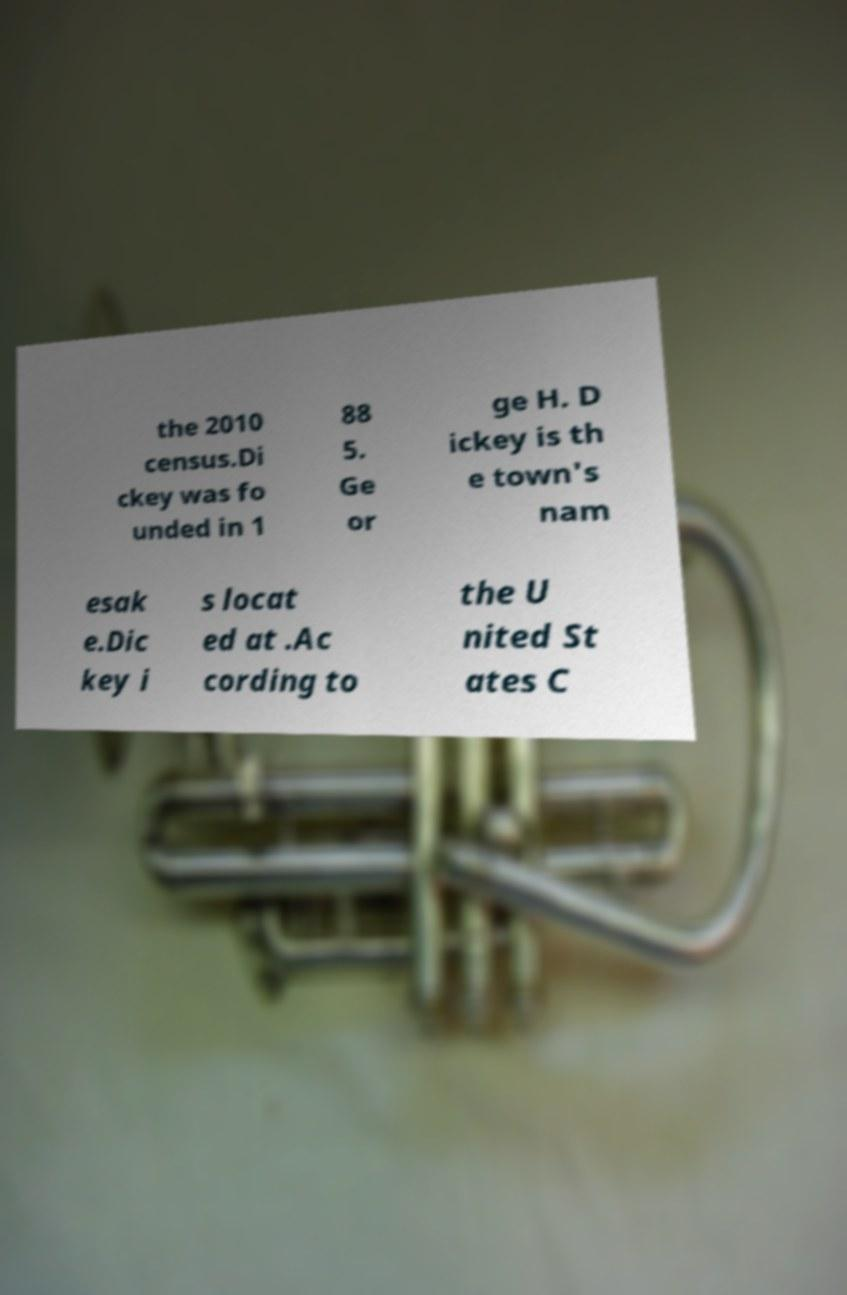Could you extract and type out the text from this image? the 2010 census.Di ckey was fo unded in 1 88 5. Ge or ge H. D ickey is th e town's nam esak e.Dic key i s locat ed at .Ac cording to the U nited St ates C 